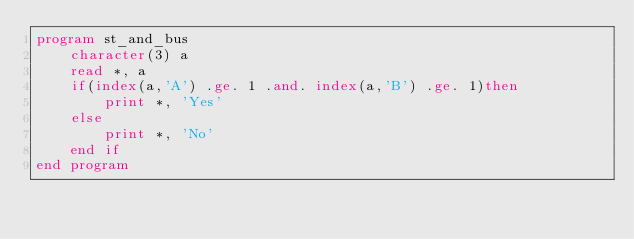<code> <loc_0><loc_0><loc_500><loc_500><_FORTRAN_>program st_and_bus
    character(3) a
    read *, a
    if(index(a,'A') .ge. 1 .and. index(a,'B') .ge. 1)then
        print *, 'Yes'
    else
        print *, 'No'
    end if
end program</code> 